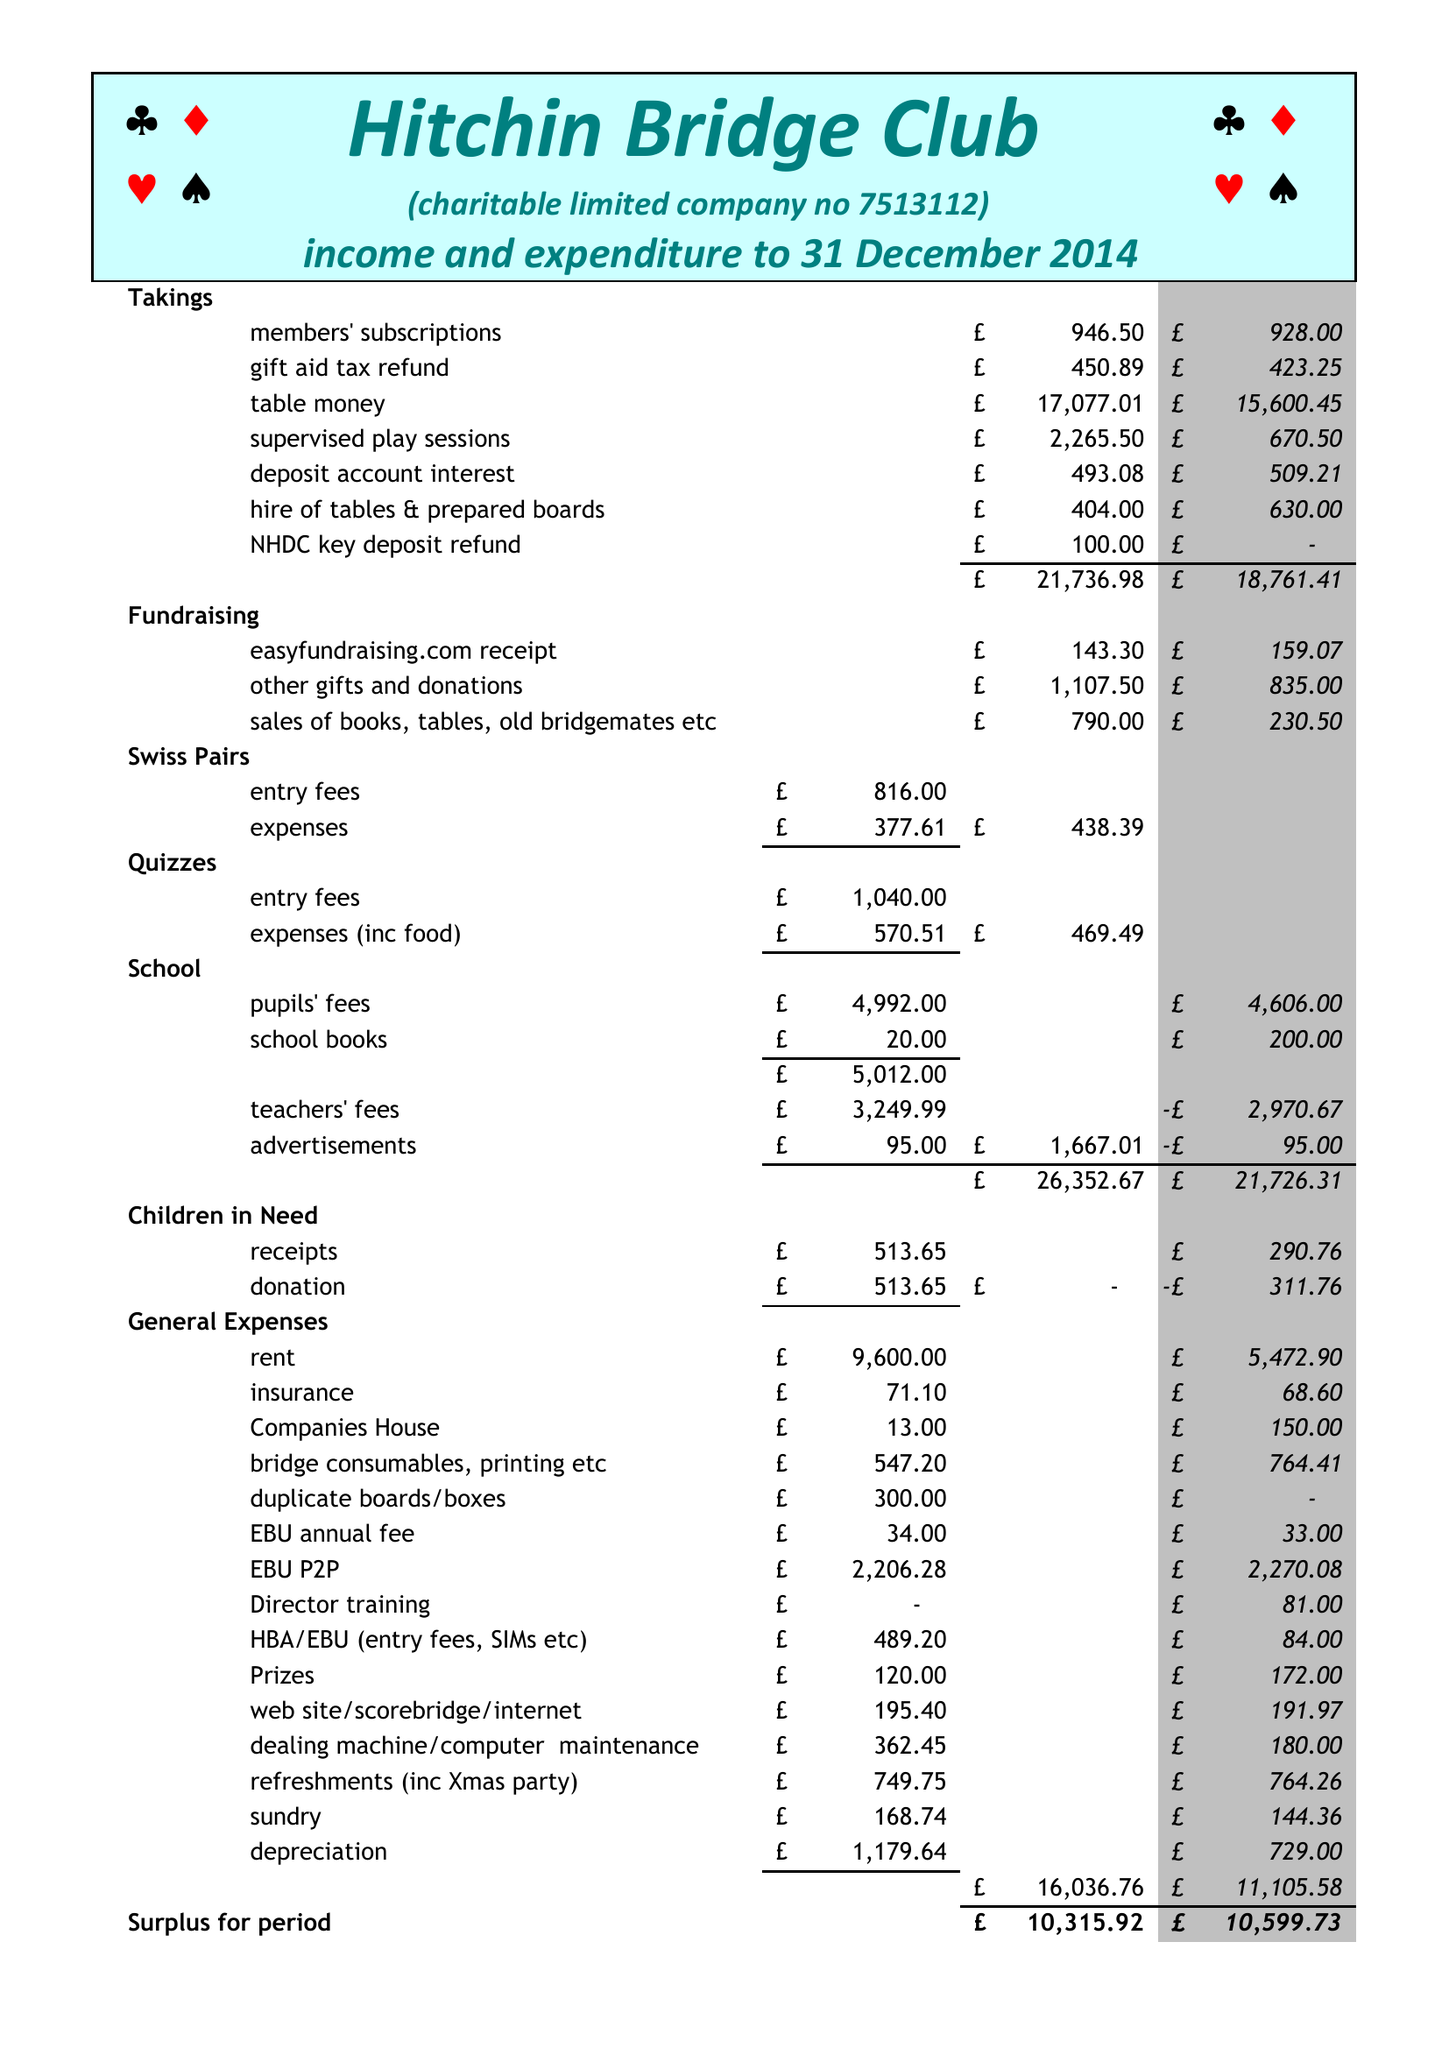What is the value for the address__street_line?
Answer the question using a single word or phrase. None 